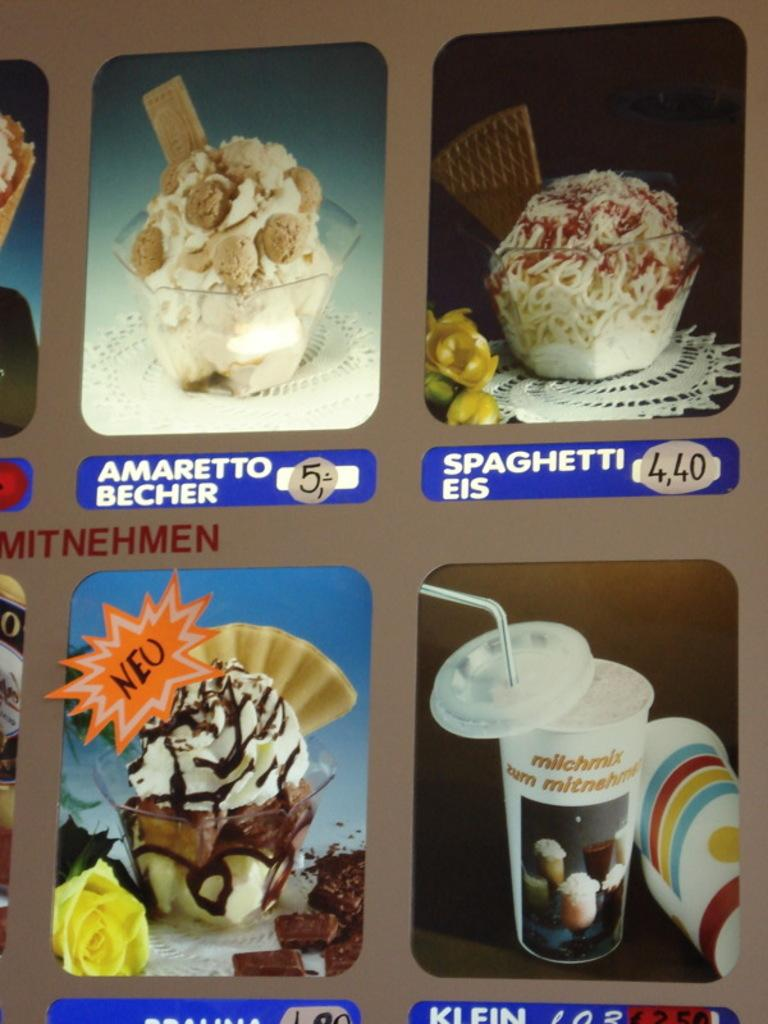What is present on the poster in the image? The poster has images of food items, texts, and numbers. Can you describe the images on the poster? The images on the poster are of food items. What colors are used in the poster? The poster has texts and numbers, but the background color of the image is gray. Can you tell me how many goats are depicted on the poster? There are no goats depicted on the poster; it features images of food items. What type of stew is being prepared in the image? There is no stew being prepared in the image; the poster only has images of food items, texts, and numbers. 